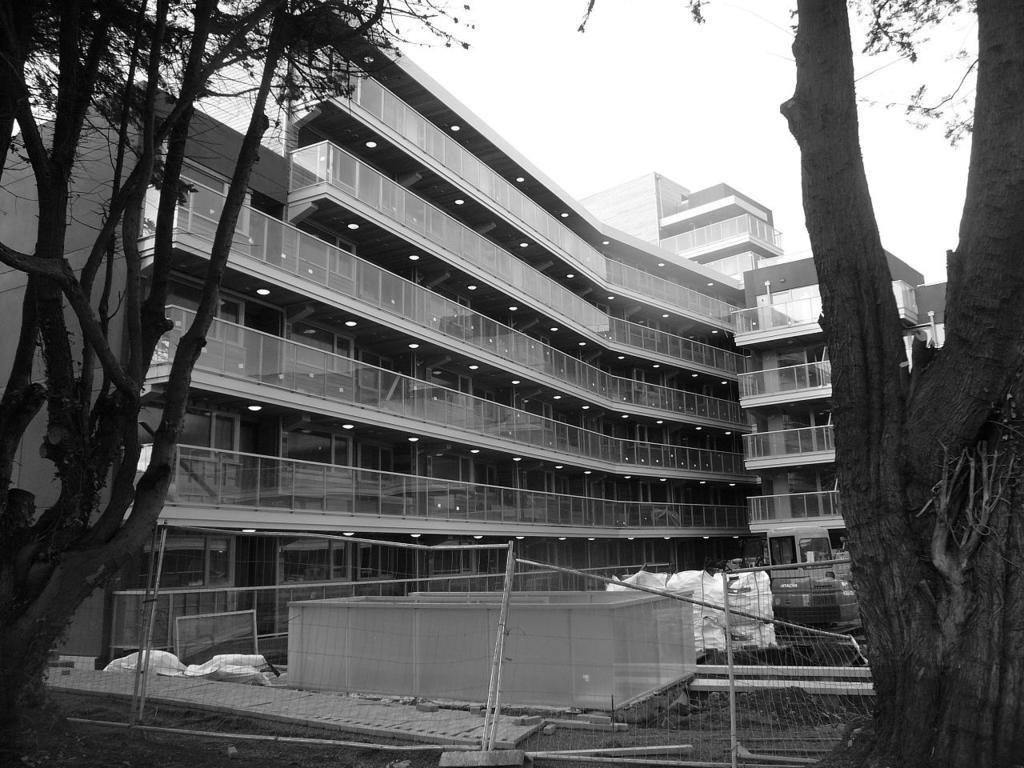Describe this image in one or two sentences. In this picture there is a glass building and there are two trees on either sides of it and there is a fence and some other objects in front of the trees. 